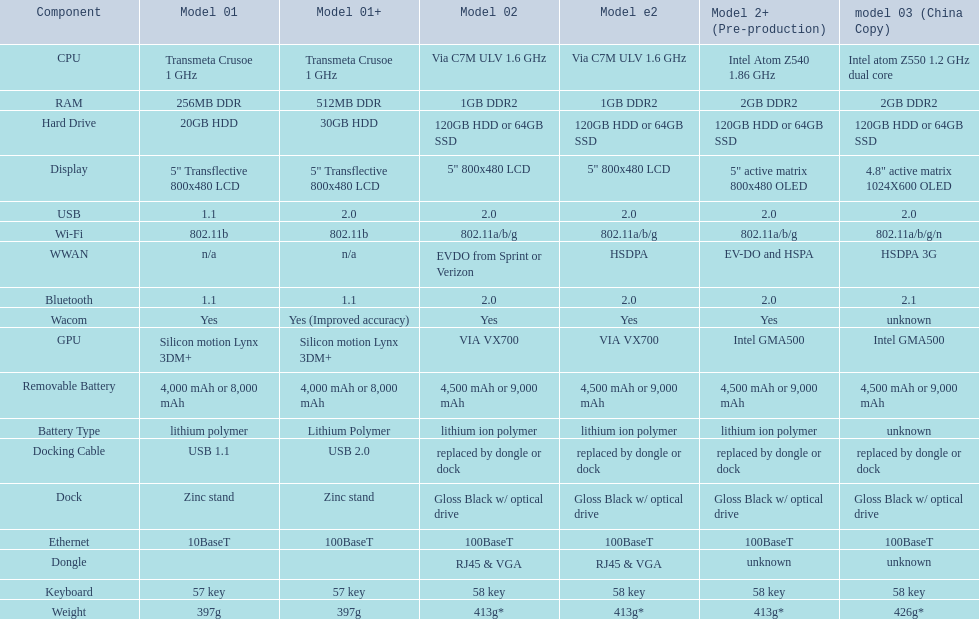0? 5. 